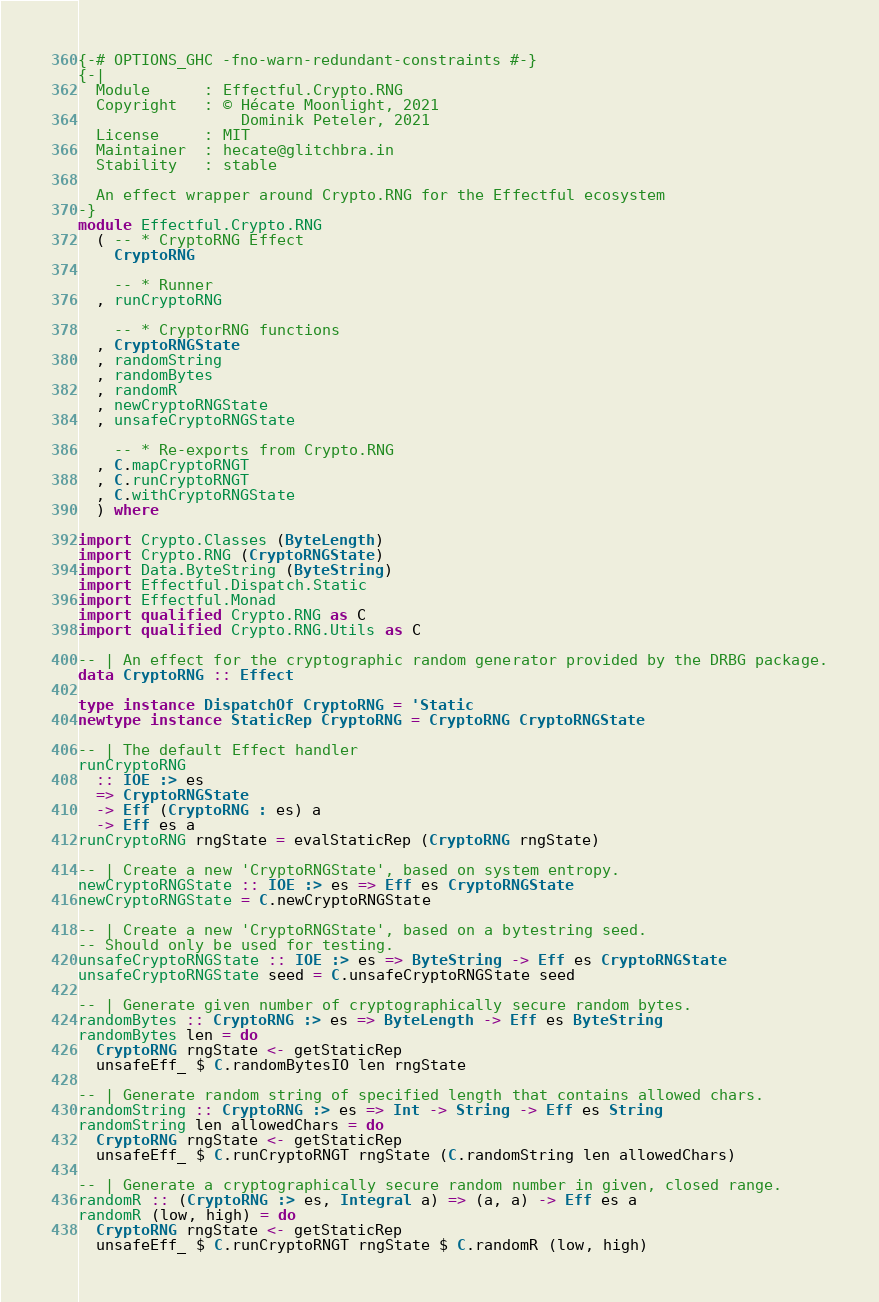Convert code to text. <code><loc_0><loc_0><loc_500><loc_500><_Haskell_>{-# OPTIONS_GHC -fno-warn-redundant-constraints #-}
{-|
  Module      : Effectful.Crypto.RNG
  Copyright   : © Hécate Moonlight, 2021
                  Dominik Peteler, 2021
  License     : MIT
  Maintainer  : hecate@glitchbra.in
  Stability   : stable

  An effect wrapper around Crypto.RNG for the Effectful ecosystem
-}
module Effectful.Crypto.RNG
  ( -- * CryptoRNG Effect
    CryptoRNG

    -- * Runner
  , runCryptoRNG

    -- * CryptorRNG functions
  , CryptoRNGState
  , randomString
  , randomBytes
  , randomR
  , newCryptoRNGState
  , unsafeCryptoRNGState

    -- * Re-exports from Crypto.RNG
  , C.mapCryptoRNGT
  , C.runCryptoRNGT
  , C.withCryptoRNGState
  ) where

import Crypto.Classes (ByteLength)
import Crypto.RNG (CryptoRNGState)
import Data.ByteString (ByteString)
import Effectful.Dispatch.Static
import Effectful.Monad
import qualified Crypto.RNG as C
import qualified Crypto.RNG.Utils as C

-- | An effect for the cryptographic random generator provided by the DRBG package.
data CryptoRNG :: Effect

type instance DispatchOf CryptoRNG = 'Static
newtype instance StaticRep CryptoRNG = CryptoRNG CryptoRNGState

-- | The default Effect handler
runCryptoRNG
  :: IOE :> es
  => CryptoRNGState
  -> Eff (CryptoRNG : es) a
  -> Eff es a
runCryptoRNG rngState = evalStaticRep (CryptoRNG rngState)

-- | Create a new 'CryptoRNGState', based on system entropy.
newCryptoRNGState :: IOE :> es => Eff es CryptoRNGState
newCryptoRNGState = C.newCryptoRNGState

-- | Create a new 'CryptoRNGState', based on a bytestring seed.
-- Should only be used for testing.
unsafeCryptoRNGState :: IOE :> es => ByteString -> Eff es CryptoRNGState
unsafeCryptoRNGState seed = C.unsafeCryptoRNGState seed

-- | Generate given number of cryptographically secure random bytes.
randomBytes :: CryptoRNG :> es => ByteLength -> Eff es ByteString
randomBytes len = do
  CryptoRNG rngState <- getStaticRep
  unsafeEff_ $ C.randomBytesIO len rngState

-- | Generate random string of specified length that contains allowed chars.
randomString :: CryptoRNG :> es => Int -> String -> Eff es String
randomString len allowedChars = do
  CryptoRNG rngState <- getStaticRep
  unsafeEff_ $ C.runCryptoRNGT rngState (C.randomString len allowedChars)

-- | Generate a cryptographically secure random number in given, closed range.
randomR :: (CryptoRNG :> es, Integral a) => (a, a) -> Eff es a
randomR (low, high) = do
  CryptoRNG rngState <- getStaticRep
  unsafeEff_ $ C.runCryptoRNGT rngState $ C.randomR (low, high)
</code> 